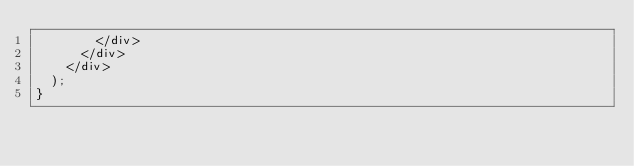Convert code to text. <code><loc_0><loc_0><loc_500><loc_500><_JavaScript_>        </div>
      </div>
    </div>
  );
}
</code> 